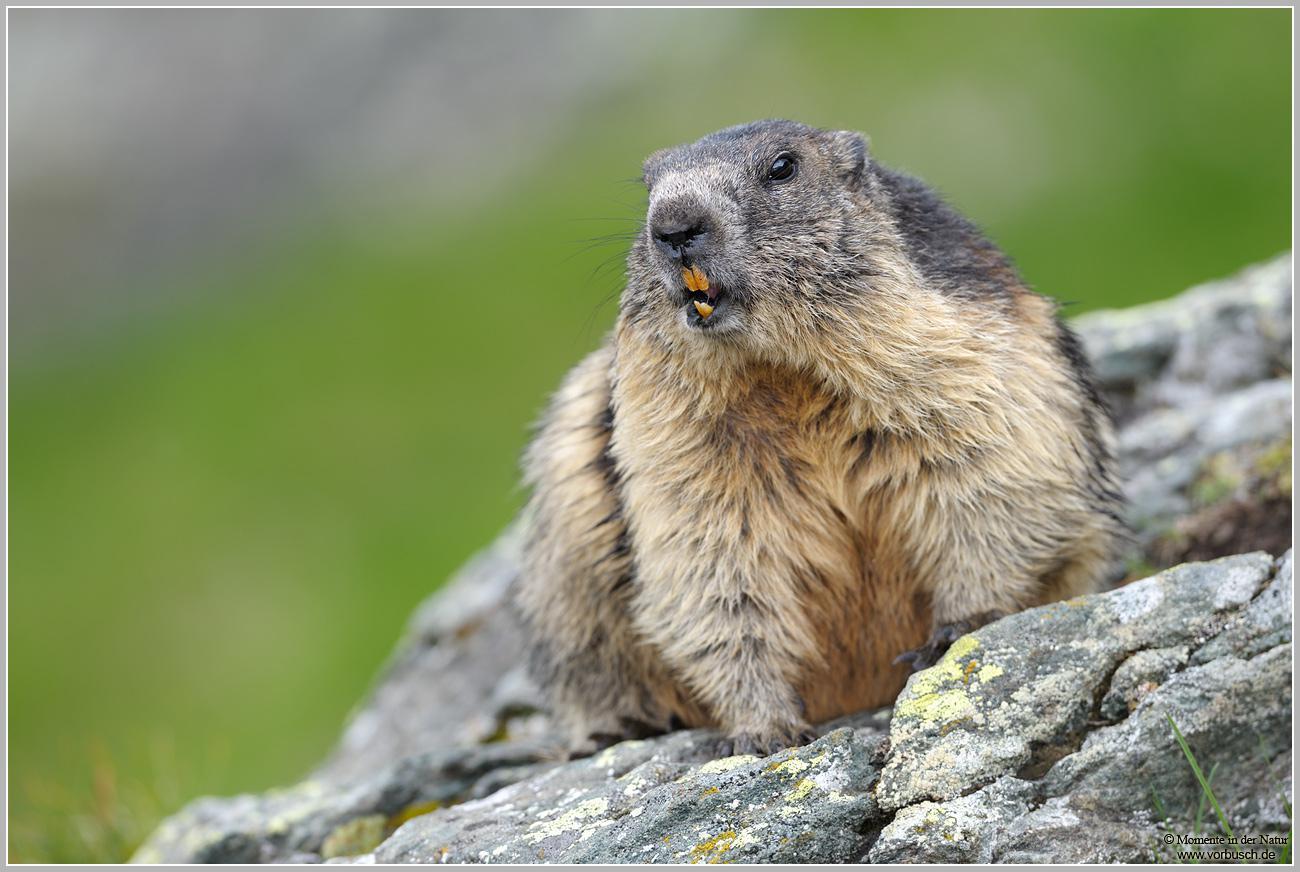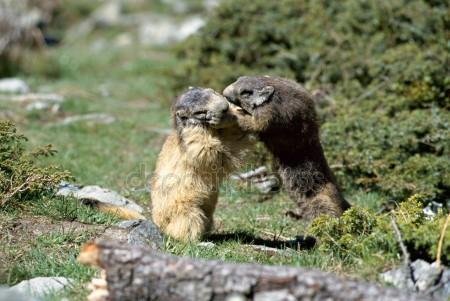The first image is the image on the left, the second image is the image on the right. For the images shown, is this caption "The marmot on the left is eating something" true? Answer yes or no. No. 